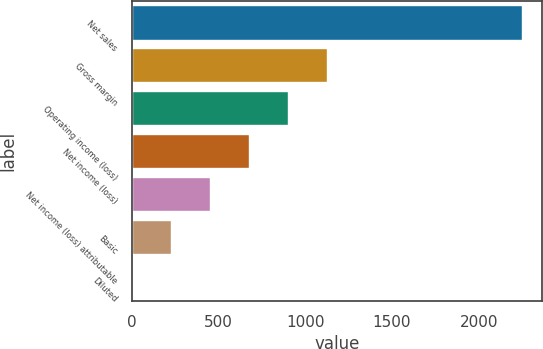Convert chart. <chart><loc_0><loc_0><loc_500><loc_500><bar_chart><fcel>Net sales<fcel>Gross margin<fcel>Operating income (loss)<fcel>Net income (loss)<fcel>Net income (loss) attributable<fcel>Basic<fcel>Diluted<nl><fcel>2252<fcel>1126.07<fcel>900.88<fcel>675.7<fcel>450.52<fcel>225.34<fcel>0.15<nl></chart> 